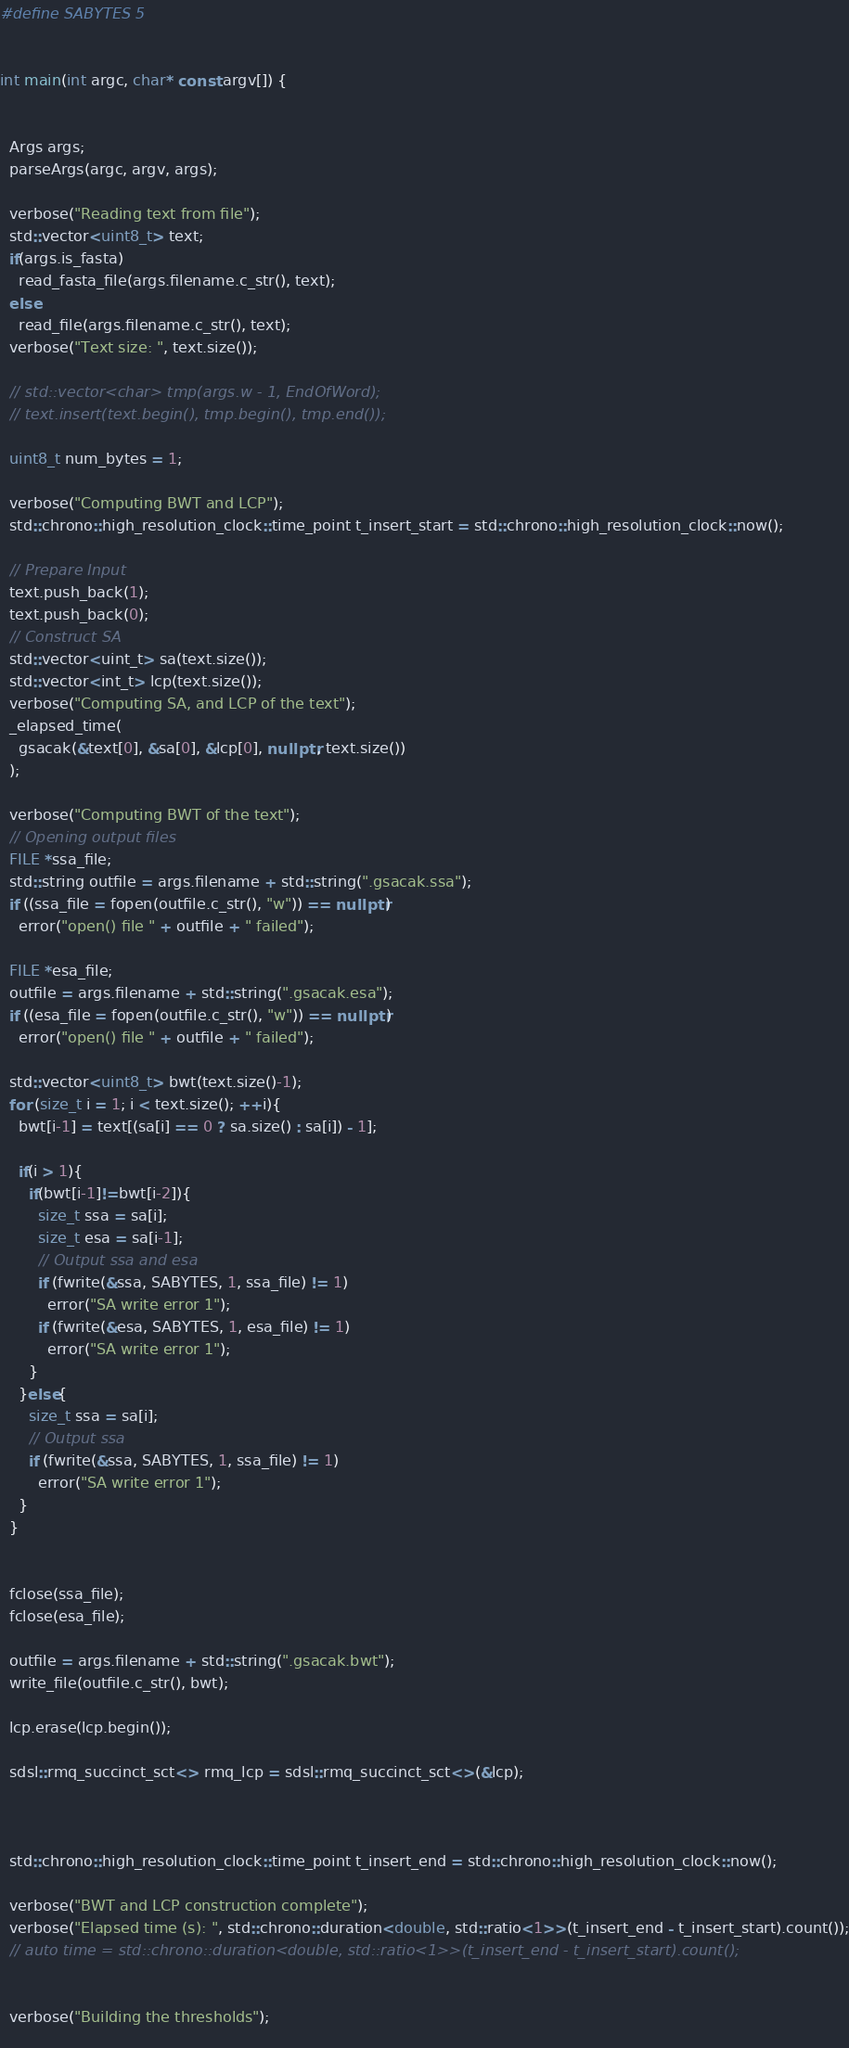Convert code to text. <code><loc_0><loc_0><loc_500><loc_500><_C++_>#define SABYTES 5


int main(int argc, char* const argv[]) {


  Args args;
  parseArgs(argc, argv, args);

  verbose("Reading text from file");
  std::vector<uint8_t> text;
  if(args.is_fasta) 
    read_fasta_file(args.filename.c_str(), text);
  else
    read_file(args.filename.c_str(), text);
  verbose("Text size: ", text.size());

  // std::vector<char> tmp(args.w - 1, EndOfWord);
  // text.insert(text.begin(), tmp.begin(), tmp.end());

  uint8_t num_bytes = 1;

  verbose("Computing BWT and LCP");
  std::chrono::high_resolution_clock::time_point t_insert_start = std::chrono::high_resolution_clock::now();

  // Prepare Input
  text.push_back(1);
  text.push_back(0);
  // Construct SA
  std::vector<uint_t> sa(text.size());
  std::vector<int_t> lcp(text.size());
  verbose("Computing SA, and LCP of the text");
  _elapsed_time(
    gsacak(&text[0], &sa[0], &lcp[0], nullptr, text.size())
  );

  verbose("Computing BWT of the text");
  // Opening output files
  FILE *ssa_file;
  std::string outfile = args.filename + std::string(".gsacak.ssa");
  if ((ssa_file = fopen(outfile.c_str(), "w")) == nullptr)
    error("open() file " + outfile + " failed");

  FILE *esa_file;
  outfile = args.filename + std::string(".gsacak.esa");
  if ((esa_file = fopen(outfile.c_str(), "w")) == nullptr)
    error("open() file " + outfile + " failed");

  std::vector<uint8_t> bwt(text.size()-1);
  for (size_t i = 1; i < text.size(); ++i){
    bwt[i-1] = text[(sa[i] == 0 ? sa.size() : sa[i]) - 1];
    
    if(i > 1){
      if(bwt[i-1]!=bwt[i-2]){
        size_t ssa = sa[i];
        size_t esa = sa[i-1];
        // Output ssa and esa
        if (fwrite(&ssa, SABYTES, 1, ssa_file) != 1)
          error("SA write error 1");
        if (fwrite(&esa, SABYTES, 1, esa_file) != 1)
          error("SA write error 1");
      }
    }else{
      size_t ssa = sa[i];
      // Output ssa
      if (fwrite(&ssa, SABYTES, 1, ssa_file) != 1)
        error("SA write error 1");
    }
  }


  fclose(ssa_file);
  fclose(esa_file);

  outfile = args.filename + std::string(".gsacak.bwt");
  write_file(outfile.c_str(), bwt);

  lcp.erase(lcp.begin());

  sdsl::rmq_succinct_sct<> rmq_lcp = sdsl::rmq_succinct_sct<>(&lcp);



  std::chrono::high_resolution_clock::time_point t_insert_end = std::chrono::high_resolution_clock::now();

  verbose("BWT and LCP construction complete");
  verbose("Elapsed time (s): ", std::chrono::duration<double, std::ratio<1>>(t_insert_end - t_insert_start).count());
  // auto time = std::chrono::duration<double, std::ratio<1>>(t_insert_end - t_insert_start).count();


  verbose("Building the thresholds");
  
</code> 